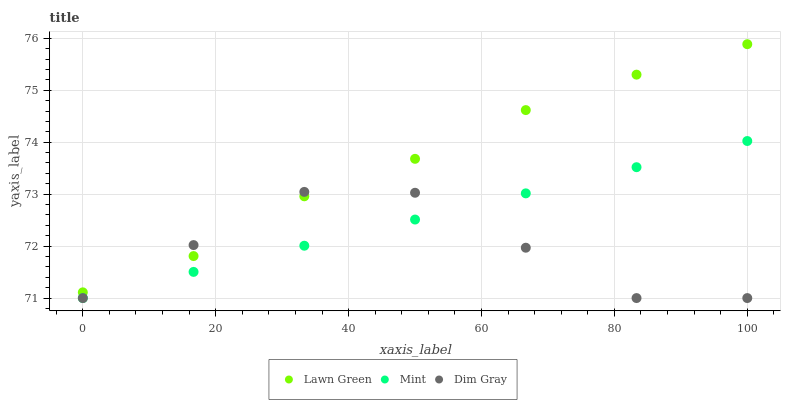Does Dim Gray have the minimum area under the curve?
Answer yes or no. Yes. Does Lawn Green have the maximum area under the curve?
Answer yes or no. Yes. Does Mint have the minimum area under the curve?
Answer yes or no. No. Does Mint have the maximum area under the curve?
Answer yes or no. No. Is Mint the smoothest?
Answer yes or no. Yes. Is Dim Gray the roughest?
Answer yes or no. Yes. Is Dim Gray the smoothest?
Answer yes or no. No. Is Mint the roughest?
Answer yes or no. No. Does Dim Gray have the lowest value?
Answer yes or no. Yes. Does Lawn Green have the highest value?
Answer yes or no. Yes. Does Mint have the highest value?
Answer yes or no. No. Is Mint less than Lawn Green?
Answer yes or no. Yes. Is Lawn Green greater than Mint?
Answer yes or no. Yes. Does Dim Gray intersect Mint?
Answer yes or no. Yes. Is Dim Gray less than Mint?
Answer yes or no. No. Is Dim Gray greater than Mint?
Answer yes or no. No. Does Mint intersect Lawn Green?
Answer yes or no. No. 